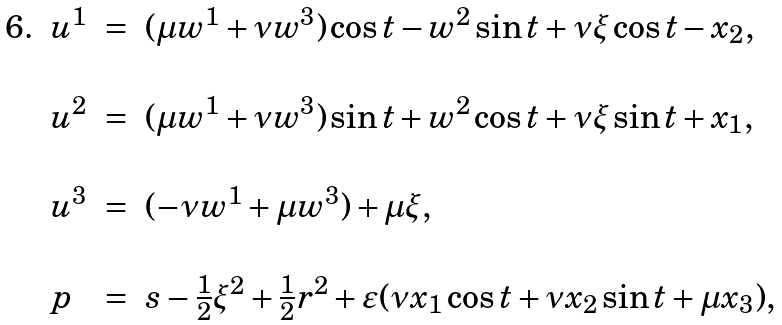Convert formula to latex. <formula><loc_0><loc_0><loc_500><loc_500>\, \begin{array} { l l l l } 6 . & u ^ { 1 } & = & ( \mu w ^ { 1 } + \nu w ^ { 3 } ) \cos t - w ^ { 2 } \sin t + \nu \xi \cos t - x _ { 2 } , \\ \\ & u ^ { 2 } & = & ( \mu w ^ { 1 } + \nu w ^ { 3 } ) \sin t + w ^ { 2 } \cos t + \nu \xi \sin t + x _ { 1 } , \\ \\ & u ^ { 3 } & = & ( - \nu w ^ { 1 } + \mu w ^ { 3 } ) + \mu \xi , \\ \\ & p & = & s - \frac { 1 } { 2 } \xi ^ { 2 } + \frac { 1 } { 2 } r ^ { 2 } + \varepsilon ( \nu x _ { 1 } \cos t + \nu x _ { 2 } \sin t + \mu x _ { 3 } ) , \end{array}</formula> 